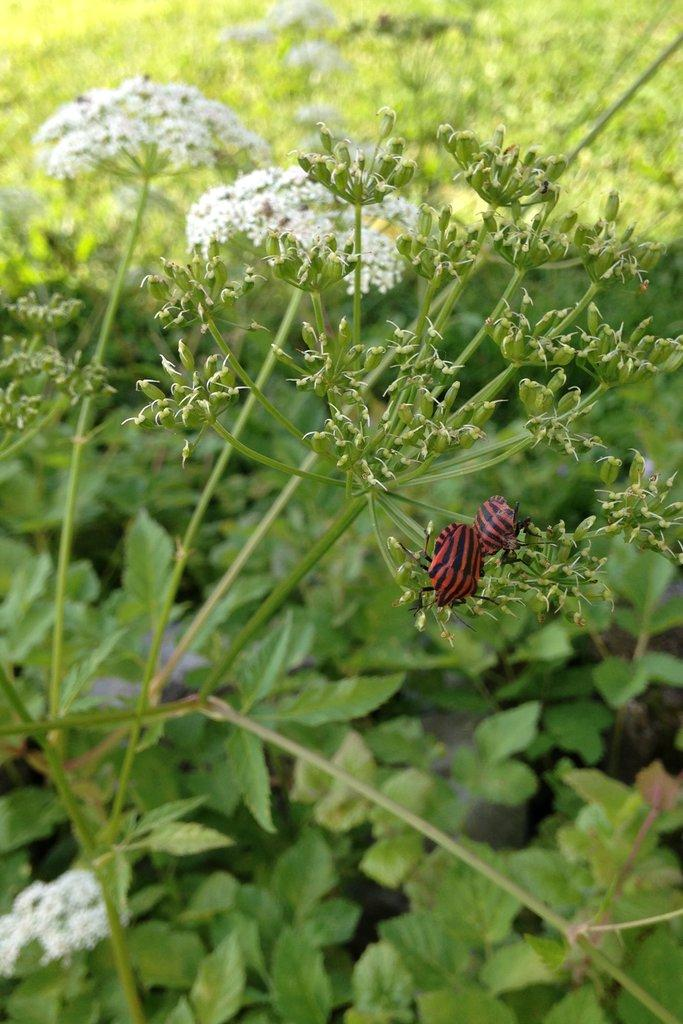What type of plants are present in the image? There are plants with white flowers in the image. Can you describe any other living organisms in the image? Yes, there is an insect above the plant in the image. What type of meat is being cooked on the roof in the image? There is no meat or roof present in the image; it features plants with white flowers and an insect. What substance is being used to create the white flowers on the plants in the image? The image does not provide information about the specific substance used to create the white flowers on the plants. 